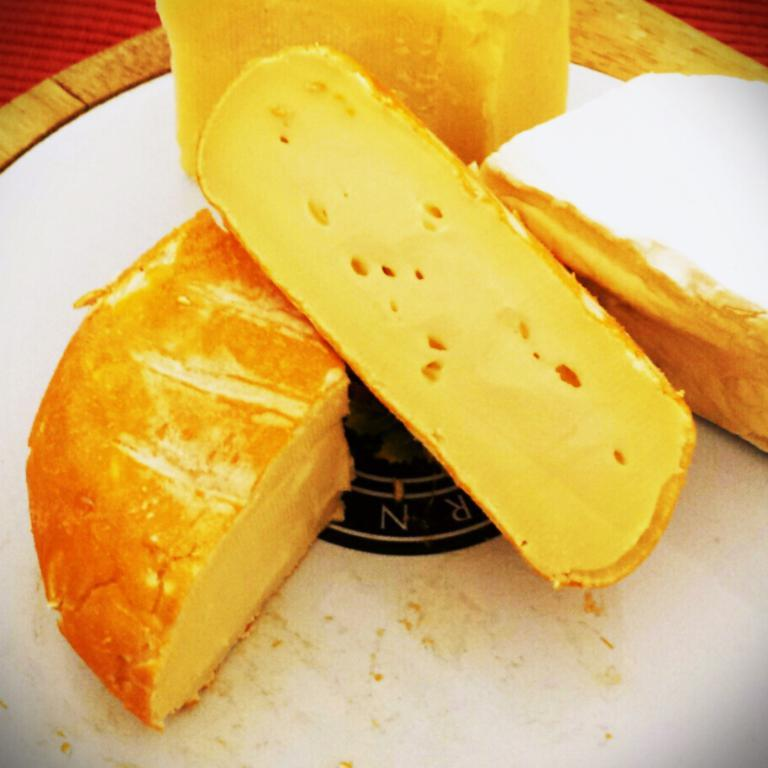What is the main subject of the image? There is a food item in the image. What is the color of the surface on which the food item is placed? The food item is on a white surface. Can you describe any other objects in the image? There is an object in the image that is red in color. What type of animal can be seen playing with a toy in the image? There is no animal or toy present in the image; it features a food item on a white surface and a red object. Can you tell me how many feathers are visible in the image? There are no feathers visible in the image. 